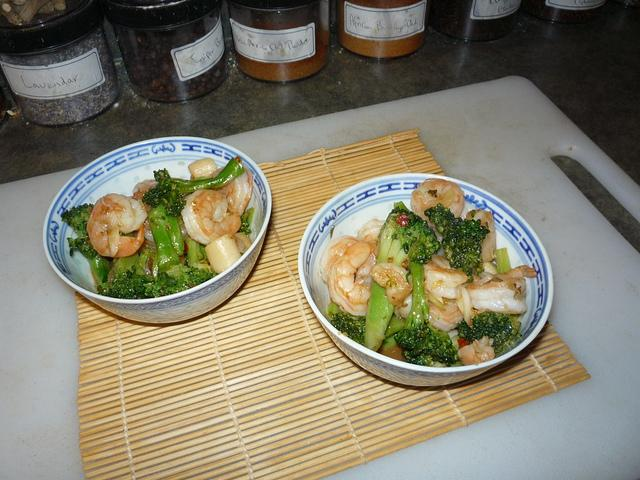If this is Chinese food how was it most likely cooked? steamed 